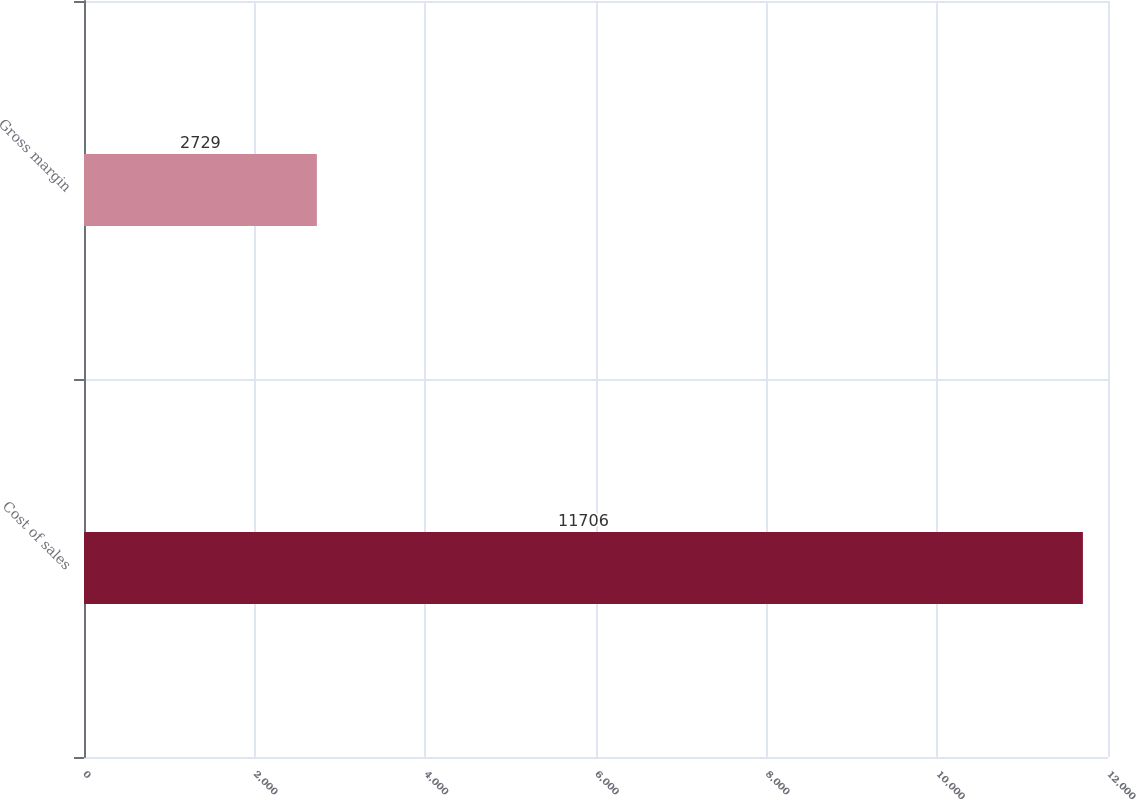Convert chart to OTSL. <chart><loc_0><loc_0><loc_500><loc_500><bar_chart><fcel>Cost of sales<fcel>Gross margin<nl><fcel>11706<fcel>2729<nl></chart> 